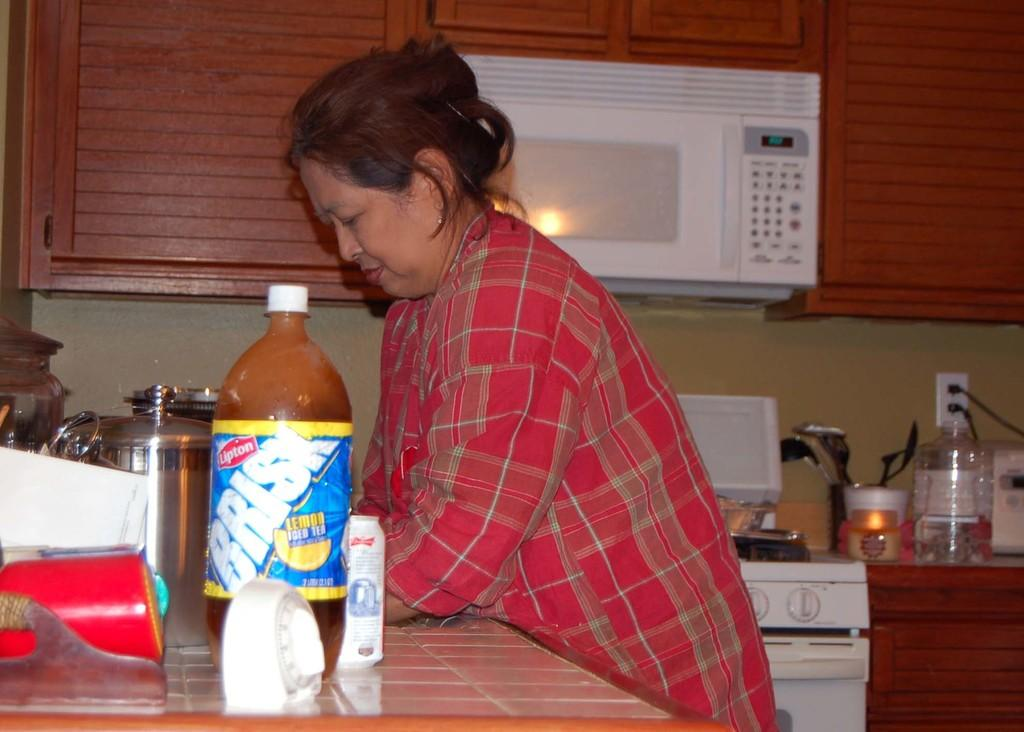Who is the main subject in the image? There is a lady in the image. What is the lady doing in the image? The lady is standing and lying on a table. What objects are on the table with the lady? There is a bottle, steel jars, and an oven on the table. What else can be seen on the table? There is a stove and a tray with spoons on the table. What is on the tray besides spoons? There are jars on the tray. Where is the mailbox located in the image? There is no mailbox present in the image. Is the lady wearing a mask in the image? The image does not show the lady wearing a mask. 